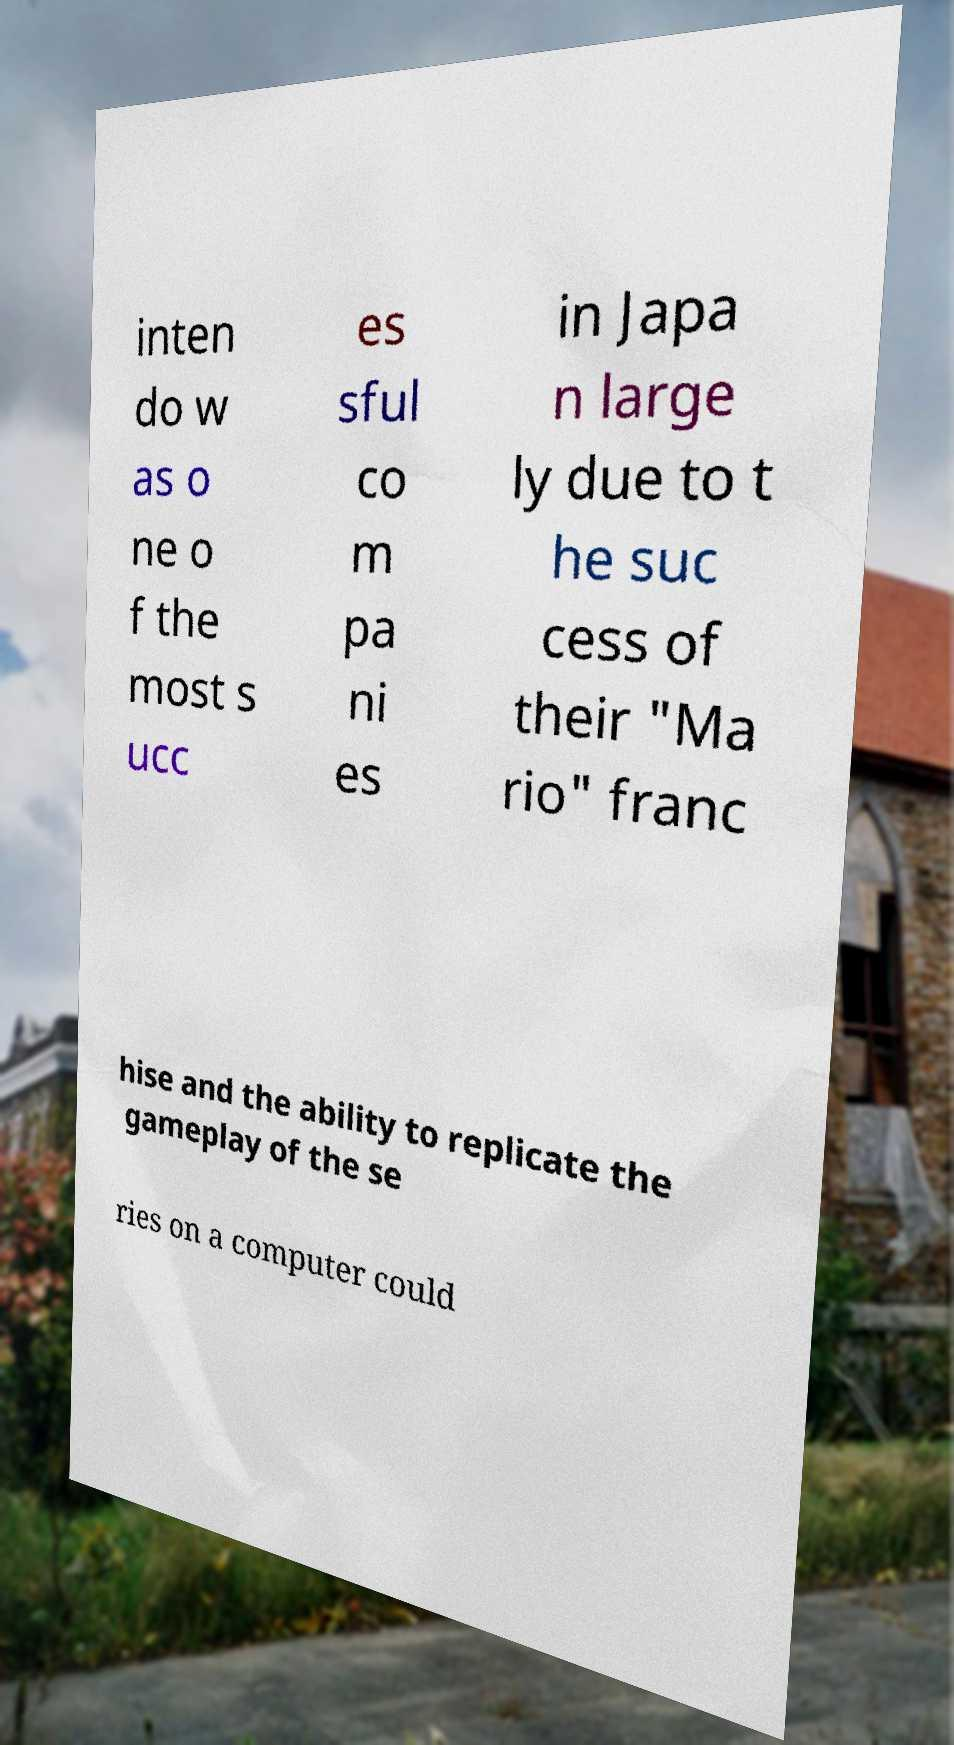What messages or text are displayed in this image? I need them in a readable, typed format. inten do w as o ne o f the most s ucc es sful co m pa ni es in Japa n large ly due to t he suc cess of their "Ma rio" franc hise and the ability to replicate the gameplay of the se ries on a computer could 